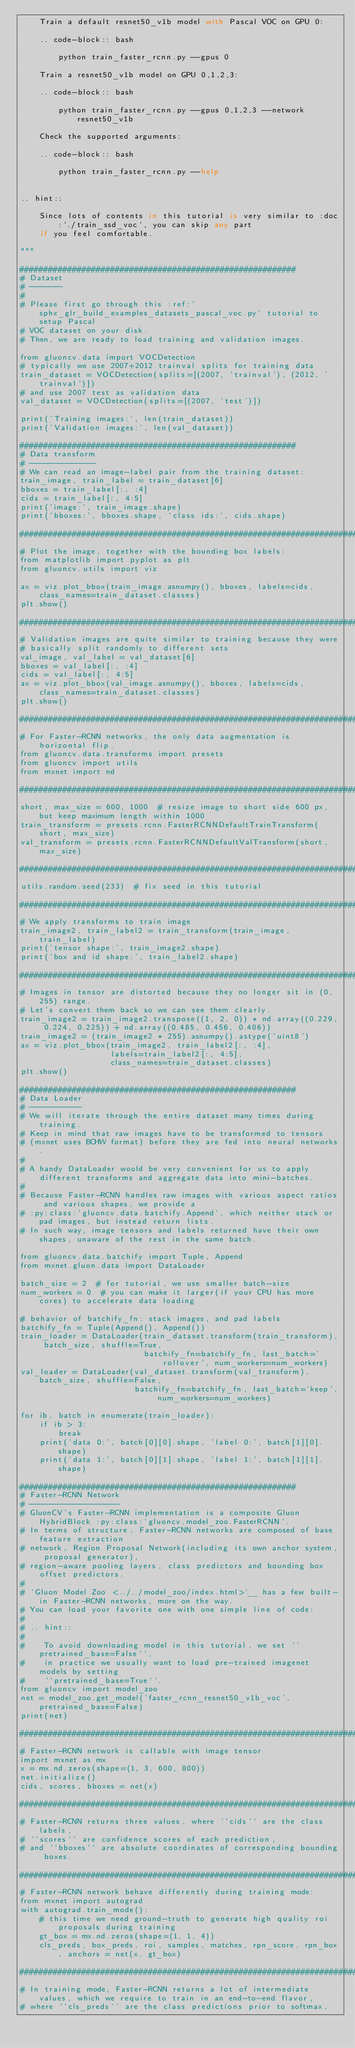Convert code to text. <code><loc_0><loc_0><loc_500><loc_500><_Python_>    Train a default resnet50_v1b model with Pascal VOC on GPU 0:

    .. code-block:: bash

        python train_faster_rcnn.py --gpus 0

    Train a resnet50_v1b model on GPU 0,1,2,3:

    .. code-block:: bash

        python train_faster_rcnn.py --gpus 0,1,2,3 --network resnet50_v1b

    Check the supported arguments:

    .. code-block:: bash

        python train_faster_rcnn.py --help


.. hint::

    Since lots of contents in this tutorial is very similar to :doc:`./train_ssd_voc`, you can skip any part
    if you feel comfortable.

"""

##########################################################
# Dataset
# -------
#
# Please first go through this :ref:`sphx_glr_build_examples_datasets_pascal_voc.py` tutorial to setup Pascal
# VOC dataset on your disk.
# Then, we are ready to load training and validation images.

from gluoncv.data import VOCDetection
# typically we use 2007+2012 trainval splits for training data
train_dataset = VOCDetection(splits=[(2007, 'trainval'), (2012, 'trainval')])
# and use 2007 test as validation data
val_dataset = VOCDetection(splits=[(2007, 'test')])

print('Training images:', len(train_dataset))
print('Validation images:', len(val_dataset))

##########################################################
# Data transform
# --------------
# We can read an image-label pair from the training dataset:
train_image, train_label = train_dataset[6]
bboxes = train_label[:, :4]
cids = train_label[:, 4:5]
print('image:', train_image.shape)
print('bboxes:', bboxes.shape, 'class ids:', cids.shape)

##############################################################################
# Plot the image, together with the bounding box labels:
from matplotlib import pyplot as plt
from gluoncv.utils import viz

ax = viz.plot_bbox(train_image.asnumpy(), bboxes, labels=cids, class_names=train_dataset.classes)
plt.show()

##############################################################################
# Validation images are quite similar to training because they were
# basically split randomly to different sets
val_image, val_label = val_dataset[6]
bboxes = val_label[:, :4]
cids = val_label[:, 4:5]
ax = viz.plot_bbox(val_image.asnumpy(), bboxes, labels=cids, class_names=train_dataset.classes)
plt.show()

##############################################################################
# For Faster-RCNN networks, the only data augmentation is horizontal flip.
from gluoncv.data.transforms import presets
from gluoncv import utils
from mxnet import nd

##############################################################################
short, max_size = 600, 1000  # resize image to short side 600 px, but keep maximum length within 1000
train_transform = presets.rcnn.FasterRCNNDefaultTrainTransform(short, max_size)
val_transform = presets.rcnn.FasterRCNNDefaultValTransform(short, max_size)

##############################################################################
utils.random.seed(233)  # fix seed in this tutorial

##############################################################################
# We apply transforms to train image
train_image2, train_label2 = train_transform(train_image, train_label)
print('tensor shape:', train_image2.shape)
print('box and id shape:', train_label2.shape)

##############################################################################
# Images in tensor are distorted because they no longer sit in (0, 255) range.
# Let's convert them back so we can see them clearly.
train_image2 = train_image2.transpose((1, 2, 0)) * nd.array((0.229, 0.224, 0.225)) + nd.array((0.485, 0.456, 0.406))
train_image2 = (train_image2 * 255).asnumpy().astype('uint8')
ax = viz.plot_bbox(train_image2, train_label2[:, :4],
                   labels=train_label2[:, 4:5],
                   class_names=train_dataset.classes)
plt.show()

##########################################################
# Data Loader
# -----------
# We will iterate through the entire dataset many times during training.
# Keep in mind that raw images have to be transformed to tensors
# (mxnet uses BCHW format) before they are fed into neural networks.
#
# A handy DataLoader would be very convenient for us to apply different transforms and aggregate data into mini-batches.
#
# Because Faster-RCNN handles raw images with various aspect ratios and various shapes, we provide a
# :py:class:`gluoncv.data.batchify.Append`, which neither stack or pad images, but instead return lists.
# In such way, image tensors and labels returned have their own shapes, unaware of the rest in the same batch.

from gluoncv.data.batchify import Tuple, Append
from mxnet.gluon.data import DataLoader

batch_size = 2  # for tutorial, we use smaller batch-size
num_workers = 0  # you can make it larger(if your CPU has more cores) to accelerate data loading

# behavior of batchify_fn: stack images, and pad labels
batchify_fn = Tuple(Append(), Append())
train_loader = DataLoader(train_dataset.transform(train_transform), batch_size, shuffle=True,
                          batchify_fn=batchify_fn, last_batch='rollover', num_workers=num_workers)
val_loader = DataLoader(val_dataset.transform(val_transform), batch_size, shuffle=False,
                        batchify_fn=batchify_fn, last_batch='keep', num_workers=num_workers)

for ib, batch in enumerate(train_loader):
    if ib > 3:
        break
    print('data 0:', batch[0][0].shape, 'label 0:', batch[1][0].shape)
    print('data 1:', batch[0][1].shape, 'label 1:', batch[1][1].shape)

##########################################################
# Faster-RCNN Network
# -------------------
# GluonCV's Faster-RCNN implementation is a composite Gluon HybridBlock :py:class:`gluoncv.model_zoo.FasterRCNN`.
# In terms of structure, Faster-RCNN networks are composed of base feature extraction
# network, Region Proposal Network(including its own anchor system, proposal generator),
# region-aware pooling layers, class predictors and bounding box offset predictors.
#
# `Gluon Model Zoo <../../model_zoo/index.html>`__ has a few built-in Faster-RCNN networks, more on the way.
# You can load your favorite one with one simple line of code:
#
# .. hint::
#
#    To avoid downloading model in this tutorial, we set ``pretrained_base=False``,
#    in practice we usually want to load pre-trained imagenet models by setting
#    ``pretrained_base=True``.
from gluoncv import model_zoo
net = model_zoo.get_model('faster_rcnn_resnet50_v1b_voc', pretrained_base=False)
print(net)

##############################################################################
# Faster-RCNN network is callable with image tensor
import mxnet as mx
x = mx.nd.zeros(shape=(1, 3, 600, 800))
net.initialize()
cids, scores, bboxes = net(x)

##############################################################################
# Faster-RCNN returns three values, where ``cids`` are the class labels,
# ``scores`` are confidence scores of each prediction,
# and ``bboxes`` are absolute coordinates of corresponding bounding boxes.

##############################################################################
# Faster-RCNN network behave differently during training mode:
from mxnet import autograd
with autograd.train_mode():
    # this time we need ground-truth to generate high quality roi proposals during training
    gt_box = mx.nd.zeros(shape=(1, 1, 4))
    cls_preds, box_preds, roi, samples, matches, rpn_score, rpn_box, anchors = net(x, gt_box)

##############################################################################
# In training mode, Faster-RCNN returns a lot of intermediate values, which we require to train in an end-to-end flavor,
# where ``cls_preds`` are the class predictions prior to softmax,</code> 